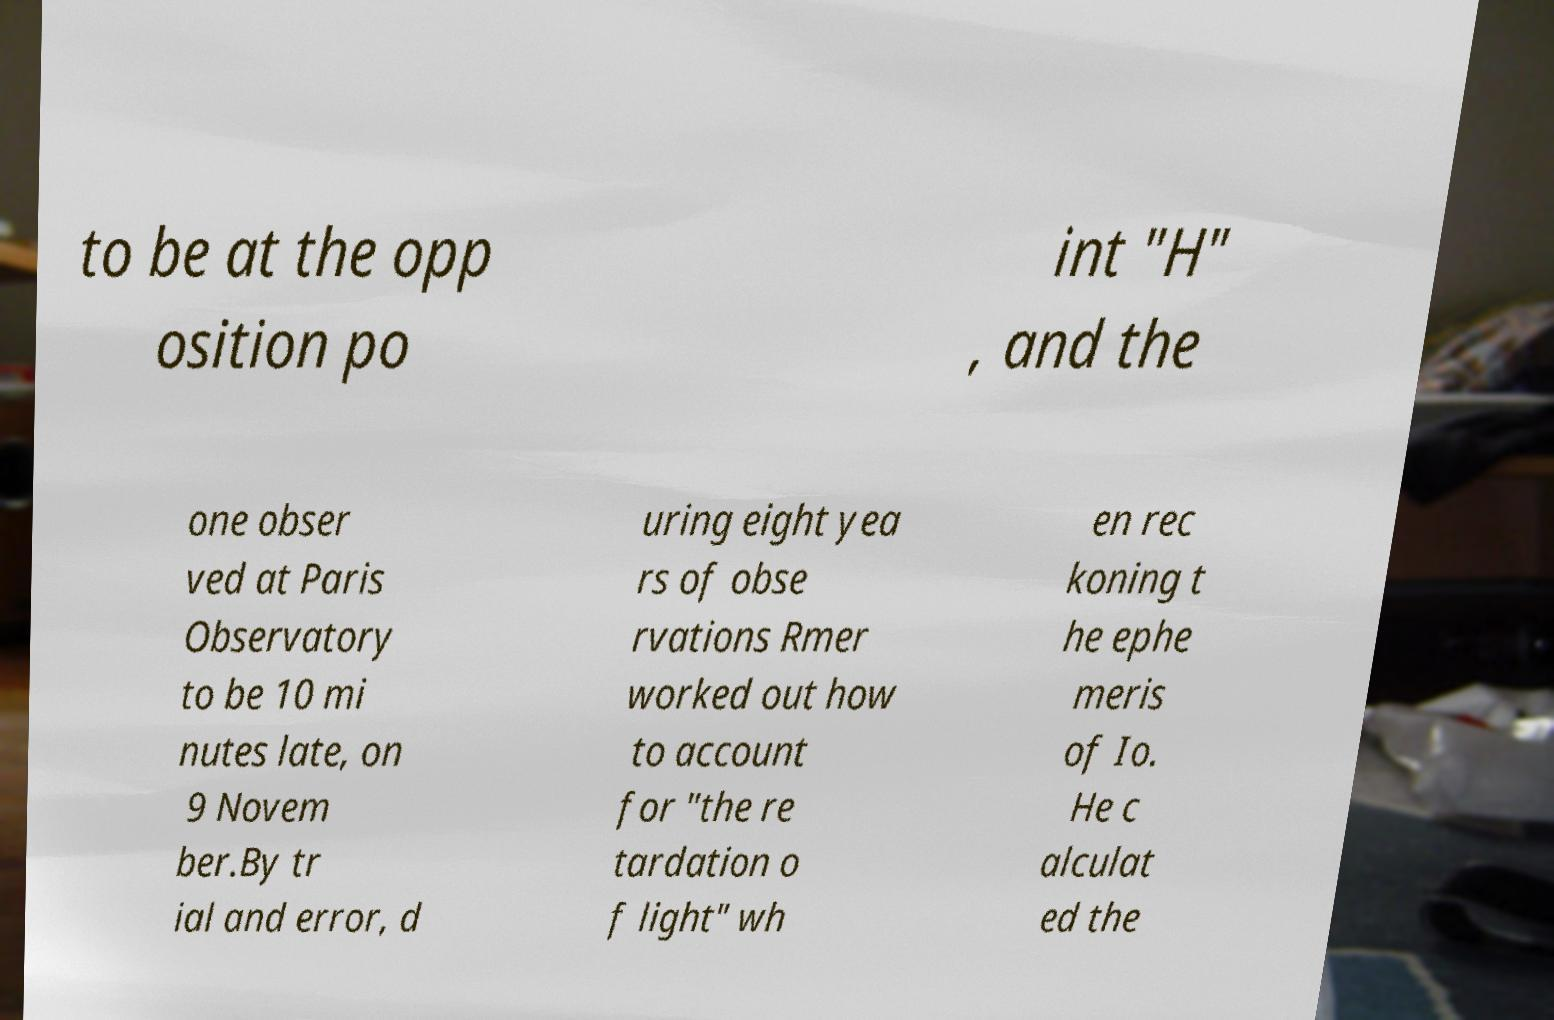Please read and relay the text visible in this image. What does it say? to be at the opp osition po int "H" , and the one obser ved at Paris Observatory to be 10 mi nutes late, on 9 Novem ber.By tr ial and error, d uring eight yea rs of obse rvations Rmer worked out how to account for "the re tardation o f light" wh en rec koning t he ephe meris of Io. He c alculat ed the 